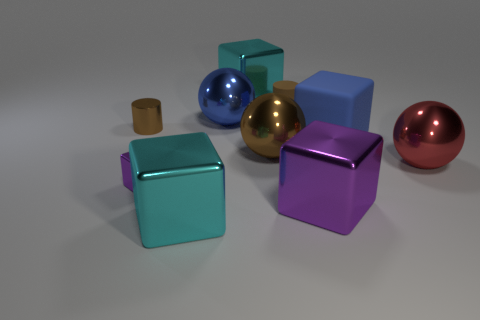Is there a metallic cylinder that has the same size as the red object?
Give a very brief answer. No. Are there fewer tiny cylinders behind the tiny block than spheres?
Ensure brevity in your answer.  Yes. What material is the cyan block in front of the cyan metal cube behind the cyan shiny cube that is in front of the big purple object?
Ensure brevity in your answer.  Metal. Are there more big cyan objects that are behind the small block than big metallic objects that are right of the red ball?
Make the answer very short. Yes. How many matte objects are either big red spheres or large brown spheres?
Ensure brevity in your answer.  0. There is a big metallic thing that is the same color as the metallic cylinder; what is its shape?
Offer a terse response. Sphere. What is the purple thing that is behind the large purple shiny block made of?
Make the answer very short. Metal. How many objects are either big blue blocks or metal objects left of the large blue cube?
Ensure brevity in your answer.  8. There is a brown object that is the same size as the blue matte cube; what is its shape?
Offer a very short reply. Sphere. How many metal balls have the same color as the small rubber cylinder?
Provide a succinct answer. 1. 